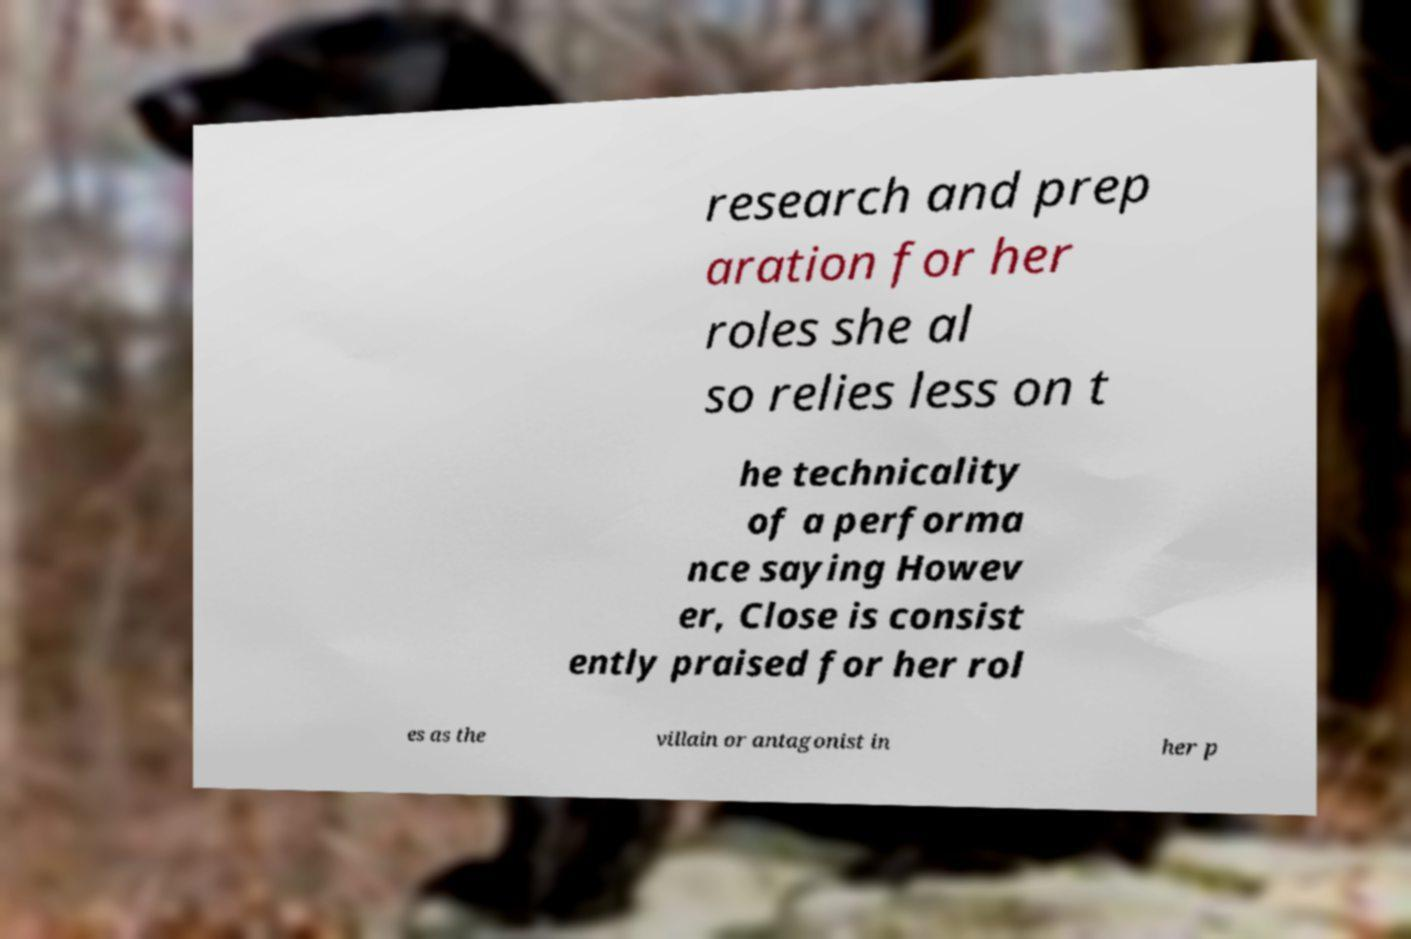Please read and relay the text visible in this image. What does it say? research and prep aration for her roles she al so relies less on t he technicality of a performa nce saying Howev er, Close is consist ently praised for her rol es as the villain or antagonist in her p 